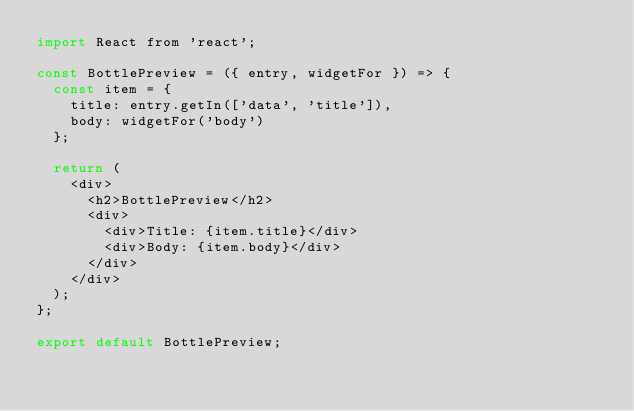Convert code to text. <code><loc_0><loc_0><loc_500><loc_500><_JavaScript_>import React from 'react';

const BottlePreview = ({ entry, widgetFor }) => {
  const item = {
    title: entry.getIn(['data', 'title']),
    body: widgetFor('body')
  };

  return (
    <div>
      <h2>BottlePreview</h2>
      <div>
        <div>Title: {item.title}</div>
        <div>Body: {item.body}</div>
      </div>
    </div>
  );
};

export default BottlePreview;
</code> 